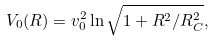<formula> <loc_0><loc_0><loc_500><loc_500>V _ { 0 } ( R ) = v _ { 0 } ^ { 2 } \ln \sqrt { 1 + R ^ { 2 } / R _ { C } ^ { 2 } } ,</formula> 